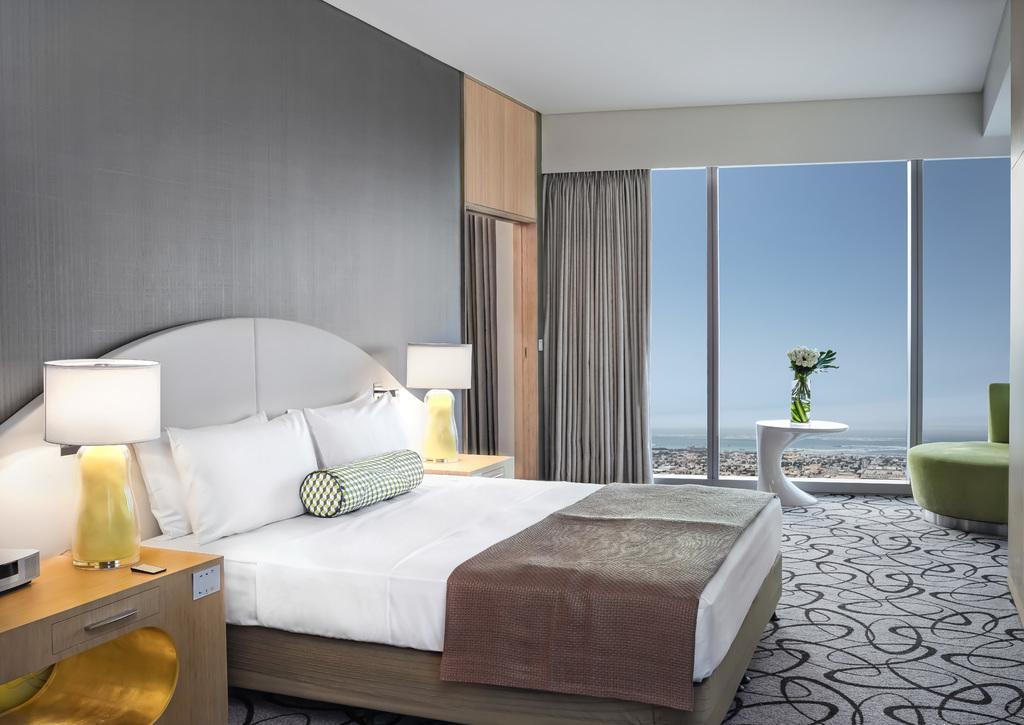Could you give a brief overview of what you see in this image? This image is clicked inside the room. In the center there is a bed, pillows, blanket. At the right side there is a green colour sofa. In the center there is a curtain and a window. At the left side lamp on the table with the remote. On the floor there is a floor mat which is grey in colour with black colour lines. 